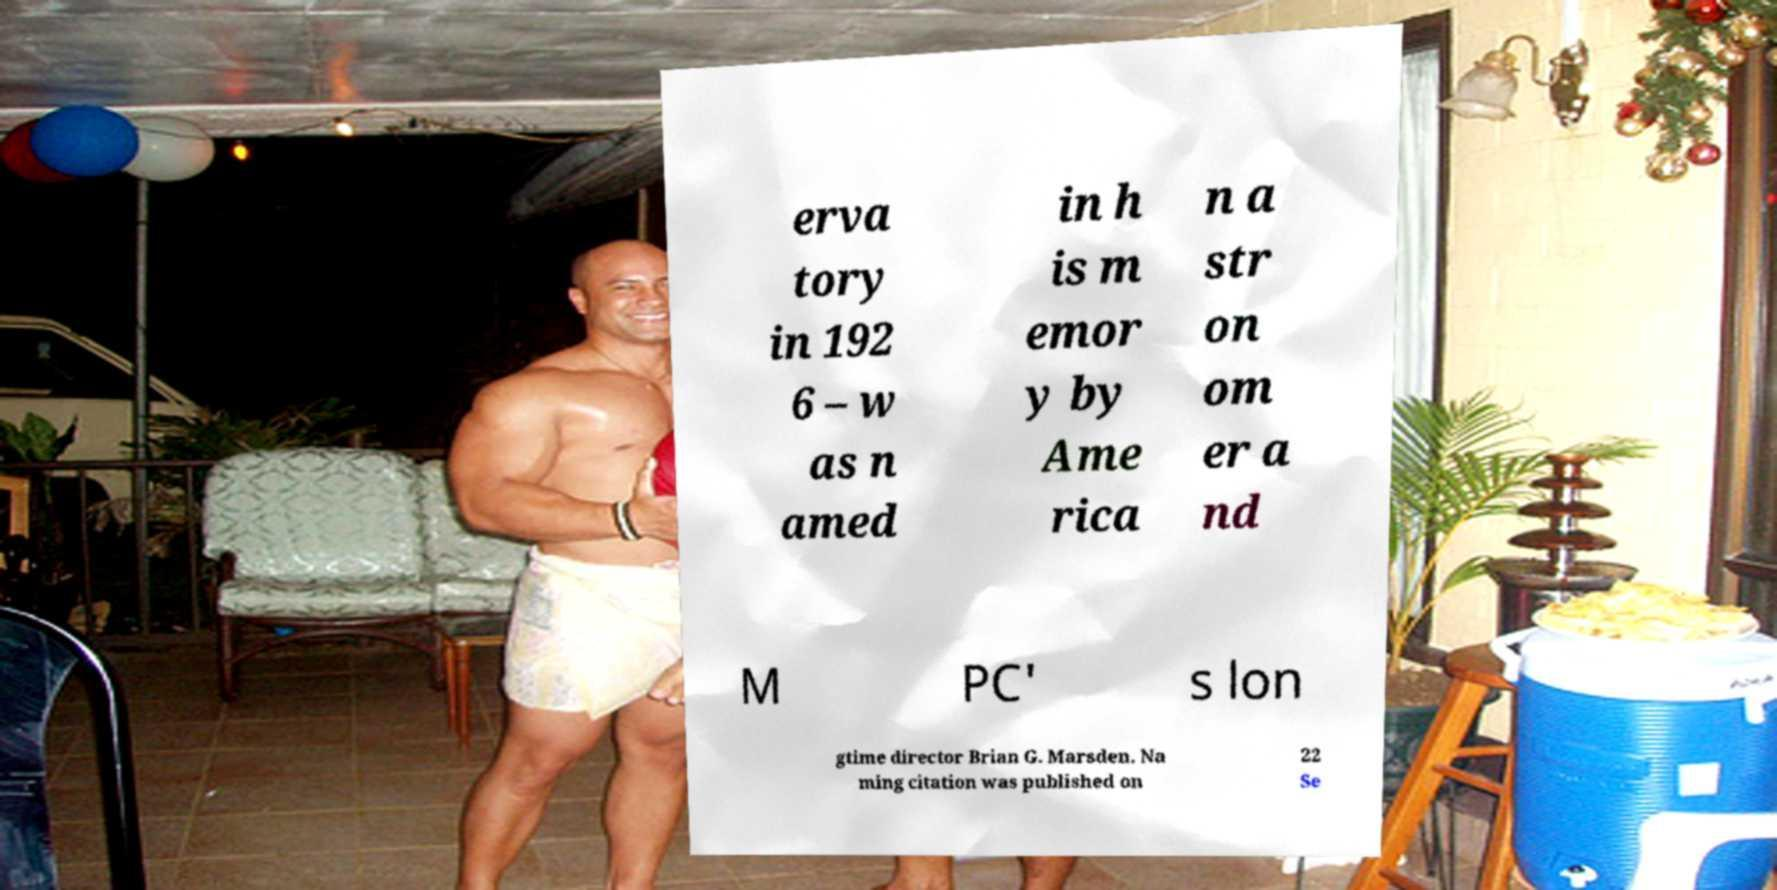What messages or text are displayed in this image? I need them in a readable, typed format. erva tory in 192 6 – w as n amed in h is m emor y by Ame rica n a str on om er a nd M PC' s lon gtime director Brian G. Marsden. Na ming citation was published on 22 Se 